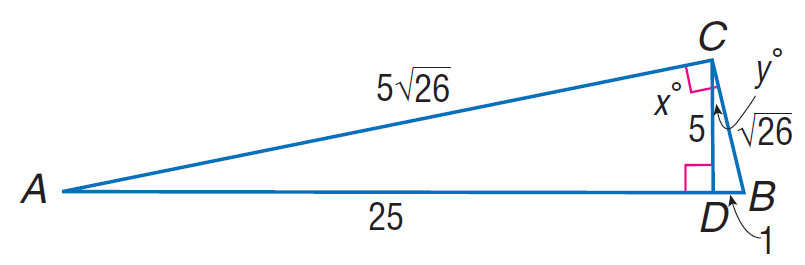Answer the mathemtical geometry problem and directly provide the correct option letter.
Question: Find \tan B.
Choices: A: 3 B: 5 C: 8 D: 10 B 